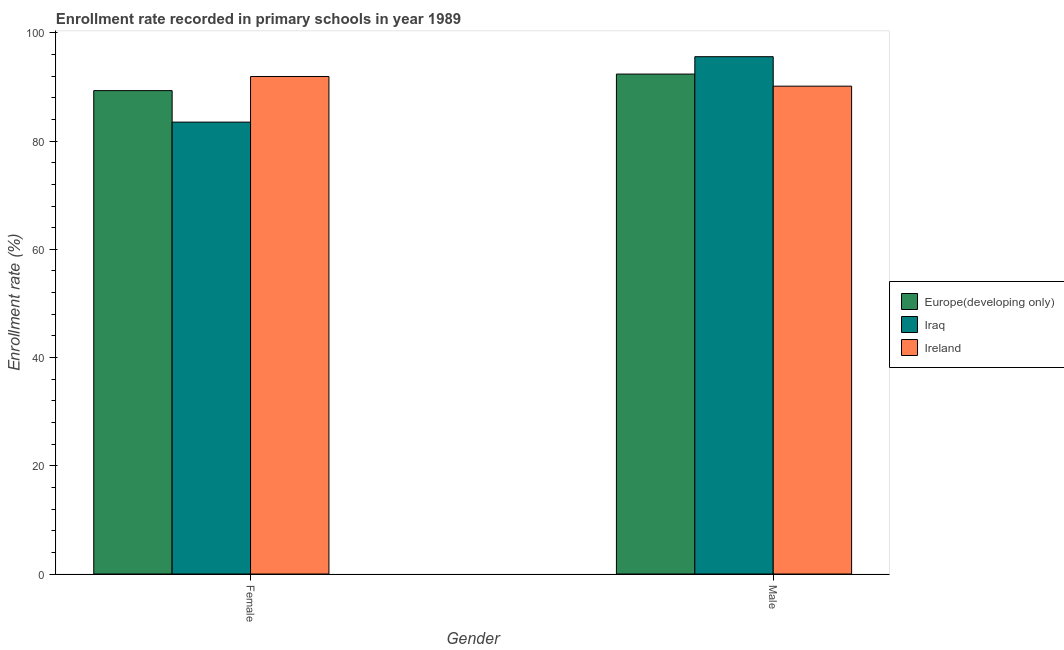Are the number of bars per tick equal to the number of legend labels?
Give a very brief answer. Yes. Are the number of bars on each tick of the X-axis equal?
Offer a terse response. Yes. How many bars are there on the 1st tick from the right?
Your response must be concise. 3. What is the enrollment rate of male students in Europe(developing only)?
Keep it short and to the point. 92.38. Across all countries, what is the maximum enrollment rate of female students?
Ensure brevity in your answer.  91.94. Across all countries, what is the minimum enrollment rate of male students?
Your answer should be compact. 90.15. In which country was the enrollment rate of female students maximum?
Your response must be concise. Ireland. In which country was the enrollment rate of female students minimum?
Ensure brevity in your answer.  Iraq. What is the total enrollment rate of male students in the graph?
Make the answer very short. 278.13. What is the difference between the enrollment rate of female students in Iraq and that in Europe(developing only)?
Provide a short and direct response. -5.82. What is the difference between the enrollment rate of female students in Iraq and the enrollment rate of male students in Ireland?
Keep it short and to the point. -6.64. What is the average enrollment rate of female students per country?
Your answer should be compact. 88.26. What is the difference between the enrollment rate of female students and enrollment rate of male students in Ireland?
Offer a very short reply. 1.79. In how many countries, is the enrollment rate of female students greater than 40 %?
Make the answer very short. 3. What is the ratio of the enrollment rate of female students in Iraq to that in Ireland?
Offer a terse response. 0.91. Is the enrollment rate of female students in Iraq less than that in Europe(developing only)?
Give a very brief answer. Yes. What does the 2nd bar from the left in Female represents?
Keep it short and to the point. Iraq. What does the 2nd bar from the right in Female represents?
Ensure brevity in your answer.  Iraq. Does the graph contain any zero values?
Keep it short and to the point. No. Where does the legend appear in the graph?
Your answer should be compact. Center right. How many legend labels are there?
Make the answer very short. 3. What is the title of the graph?
Offer a terse response. Enrollment rate recorded in primary schools in year 1989. Does "Honduras" appear as one of the legend labels in the graph?
Give a very brief answer. No. What is the label or title of the Y-axis?
Offer a very short reply. Enrollment rate (%). What is the Enrollment rate (%) of Europe(developing only) in Female?
Your answer should be very brief. 89.32. What is the Enrollment rate (%) in Iraq in Female?
Make the answer very short. 83.51. What is the Enrollment rate (%) in Ireland in Female?
Offer a terse response. 91.94. What is the Enrollment rate (%) in Europe(developing only) in Male?
Provide a succinct answer. 92.38. What is the Enrollment rate (%) of Iraq in Male?
Provide a short and direct response. 95.6. What is the Enrollment rate (%) in Ireland in Male?
Your answer should be very brief. 90.15. Across all Gender, what is the maximum Enrollment rate (%) of Europe(developing only)?
Your response must be concise. 92.38. Across all Gender, what is the maximum Enrollment rate (%) in Iraq?
Ensure brevity in your answer.  95.6. Across all Gender, what is the maximum Enrollment rate (%) in Ireland?
Keep it short and to the point. 91.94. Across all Gender, what is the minimum Enrollment rate (%) of Europe(developing only)?
Provide a succinct answer. 89.32. Across all Gender, what is the minimum Enrollment rate (%) of Iraq?
Offer a very short reply. 83.51. Across all Gender, what is the minimum Enrollment rate (%) of Ireland?
Offer a terse response. 90.15. What is the total Enrollment rate (%) of Europe(developing only) in the graph?
Keep it short and to the point. 181.71. What is the total Enrollment rate (%) in Iraq in the graph?
Give a very brief answer. 179.1. What is the total Enrollment rate (%) of Ireland in the graph?
Your response must be concise. 182.09. What is the difference between the Enrollment rate (%) in Europe(developing only) in Female and that in Male?
Your response must be concise. -3.06. What is the difference between the Enrollment rate (%) in Iraq in Female and that in Male?
Keep it short and to the point. -12.09. What is the difference between the Enrollment rate (%) of Ireland in Female and that in Male?
Your response must be concise. 1.79. What is the difference between the Enrollment rate (%) in Europe(developing only) in Female and the Enrollment rate (%) in Iraq in Male?
Offer a very short reply. -6.27. What is the difference between the Enrollment rate (%) in Europe(developing only) in Female and the Enrollment rate (%) in Ireland in Male?
Offer a very short reply. -0.83. What is the difference between the Enrollment rate (%) of Iraq in Female and the Enrollment rate (%) of Ireland in Male?
Ensure brevity in your answer.  -6.64. What is the average Enrollment rate (%) in Europe(developing only) per Gender?
Keep it short and to the point. 90.85. What is the average Enrollment rate (%) in Iraq per Gender?
Make the answer very short. 89.55. What is the average Enrollment rate (%) of Ireland per Gender?
Ensure brevity in your answer.  91.04. What is the difference between the Enrollment rate (%) in Europe(developing only) and Enrollment rate (%) in Iraq in Female?
Give a very brief answer. 5.82. What is the difference between the Enrollment rate (%) of Europe(developing only) and Enrollment rate (%) of Ireland in Female?
Ensure brevity in your answer.  -2.61. What is the difference between the Enrollment rate (%) in Iraq and Enrollment rate (%) in Ireland in Female?
Ensure brevity in your answer.  -8.43. What is the difference between the Enrollment rate (%) of Europe(developing only) and Enrollment rate (%) of Iraq in Male?
Offer a terse response. -3.21. What is the difference between the Enrollment rate (%) of Europe(developing only) and Enrollment rate (%) of Ireland in Male?
Your response must be concise. 2.23. What is the difference between the Enrollment rate (%) of Iraq and Enrollment rate (%) of Ireland in Male?
Keep it short and to the point. 5.45. What is the ratio of the Enrollment rate (%) in Europe(developing only) in Female to that in Male?
Keep it short and to the point. 0.97. What is the ratio of the Enrollment rate (%) of Iraq in Female to that in Male?
Ensure brevity in your answer.  0.87. What is the ratio of the Enrollment rate (%) of Ireland in Female to that in Male?
Your answer should be very brief. 1.02. What is the difference between the highest and the second highest Enrollment rate (%) in Europe(developing only)?
Your response must be concise. 3.06. What is the difference between the highest and the second highest Enrollment rate (%) in Iraq?
Provide a succinct answer. 12.09. What is the difference between the highest and the second highest Enrollment rate (%) of Ireland?
Ensure brevity in your answer.  1.79. What is the difference between the highest and the lowest Enrollment rate (%) in Europe(developing only)?
Your answer should be very brief. 3.06. What is the difference between the highest and the lowest Enrollment rate (%) in Iraq?
Offer a very short reply. 12.09. What is the difference between the highest and the lowest Enrollment rate (%) of Ireland?
Offer a terse response. 1.79. 